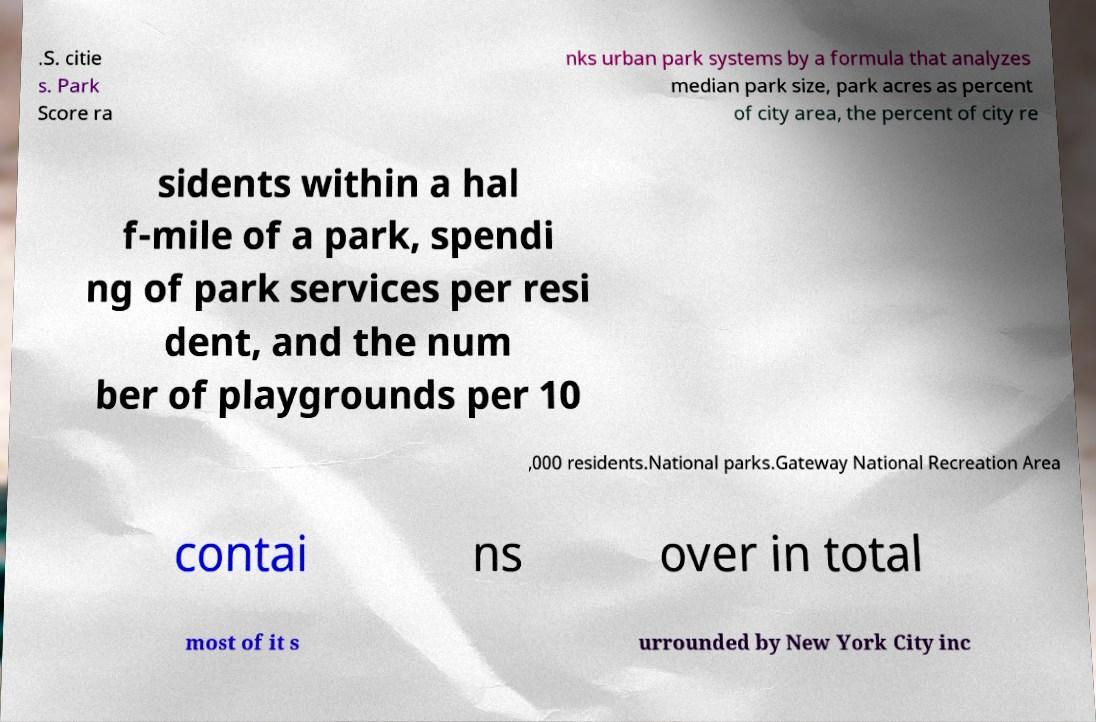Can you accurately transcribe the text from the provided image for me? .S. citie s. Park Score ra nks urban park systems by a formula that analyzes median park size, park acres as percent of city area, the percent of city re sidents within a hal f-mile of a park, spendi ng of park services per resi dent, and the num ber of playgrounds per 10 ,000 residents.National parks.Gateway National Recreation Area contai ns over in total most of it s urrounded by New York City inc 